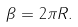<formula> <loc_0><loc_0><loc_500><loc_500>\beta = 2 \pi R .</formula> 